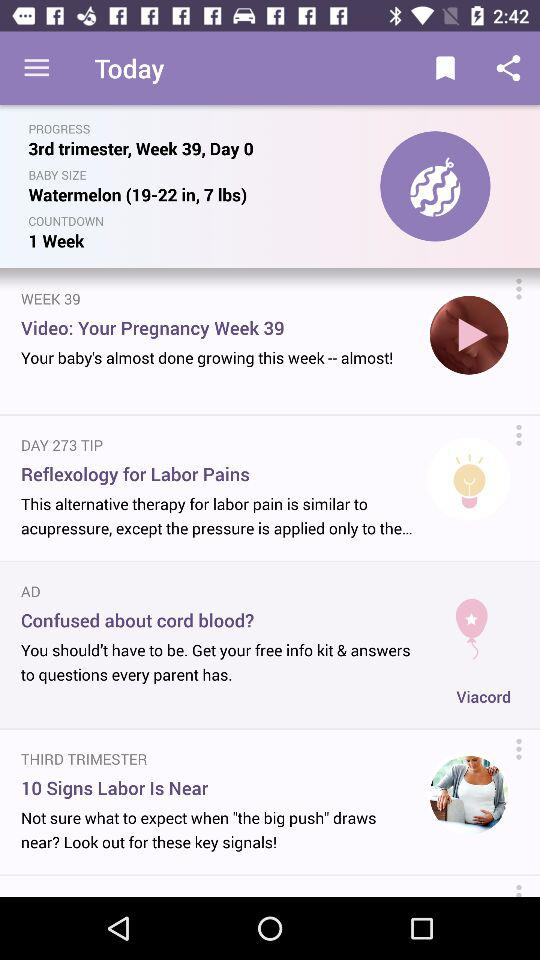What is the pregnancy week number? The pregnancy week number is 39. 